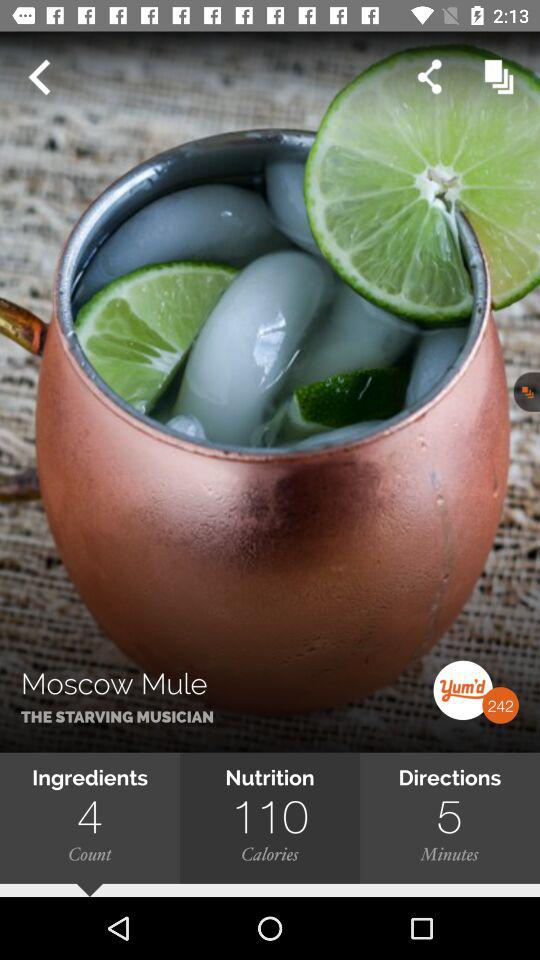What is the name of the drink? The name of the drink is "Moscow Mule". 